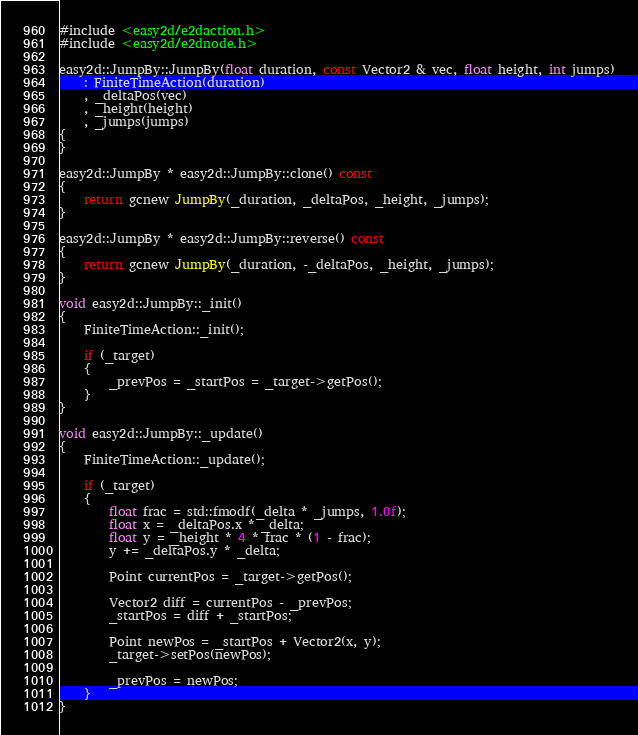<code> <loc_0><loc_0><loc_500><loc_500><_C++_>#include <easy2d/e2daction.h>
#include <easy2d/e2dnode.h>

easy2d::JumpBy::JumpBy(float duration, const Vector2 & vec, float height, int jumps)
	: FiniteTimeAction(duration)
	, _deltaPos(vec)
	, _height(height)
	, _jumps(jumps)
{
}

easy2d::JumpBy * easy2d::JumpBy::clone() const
{
	return gcnew JumpBy(_duration, _deltaPos, _height, _jumps);
}

easy2d::JumpBy * easy2d::JumpBy::reverse() const
{
	return gcnew JumpBy(_duration, -_deltaPos, _height, _jumps);
}

void easy2d::JumpBy::_init()
{
	FiniteTimeAction::_init();

	if (_target)
	{
		_prevPos = _startPos = _target->getPos();
	}
}

void easy2d::JumpBy::_update()
{
	FiniteTimeAction::_update();

	if (_target)
	{
		float frac = std::fmodf(_delta * _jumps, 1.0f);
		float x = _deltaPos.x * _delta;
		float y = _height * 4 * frac * (1 - frac);
		y += _deltaPos.y * _delta;

		Point currentPos = _target->getPos();

		Vector2 diff = currentPos - _prevPos;
		_startPos = diff + _startPos;

		Point newPos = _startPos + Vector2(x, y);
		_target->setPos(newPos);

		_prevPos = newPos;
	}
}
</code> 